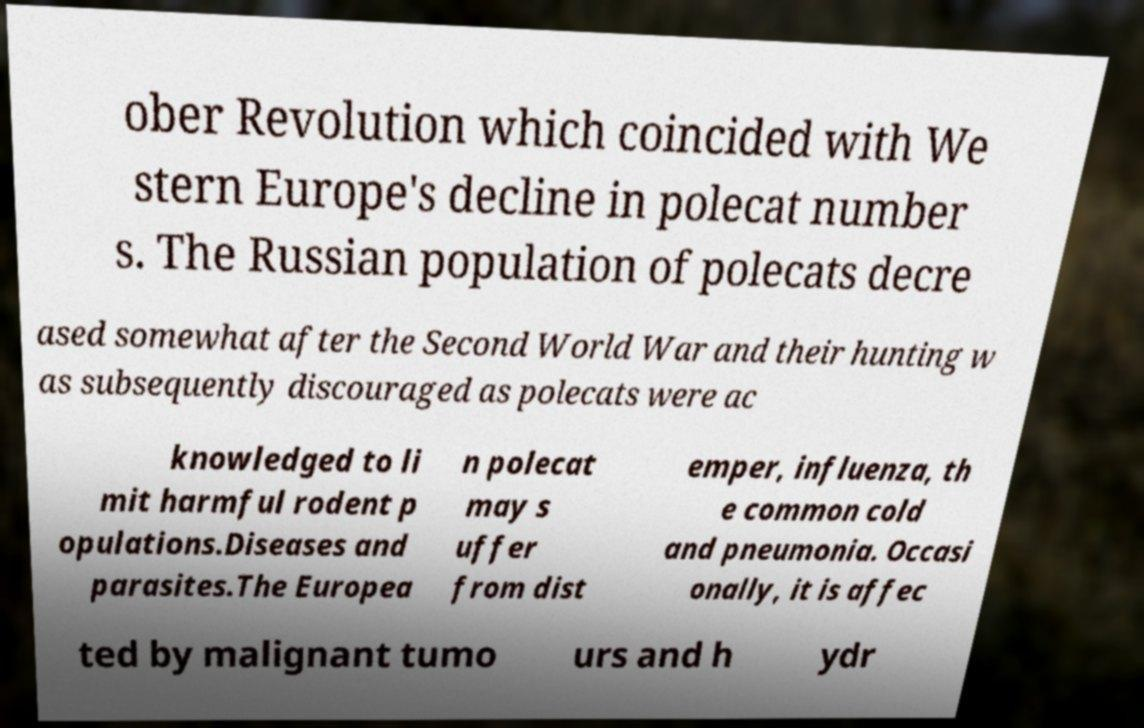What messages or text are displayed in this image? I need them in a readable, typed format. ober Revolution which coincided with We stern Europe's decline in polecat number s. The Russian population of polecats decre ased somewhat after the Second World War and their hunting w as subsequently discouraged as polecats were ac knowledged to li mit harmful rodent p opulations.Diseases and parasites.The Europea n polecat may s uffer from dist emper, influenza, th e common cold and pneumonia. Occasi onally, it is affec ted by malignant tumo urs and h ydr 